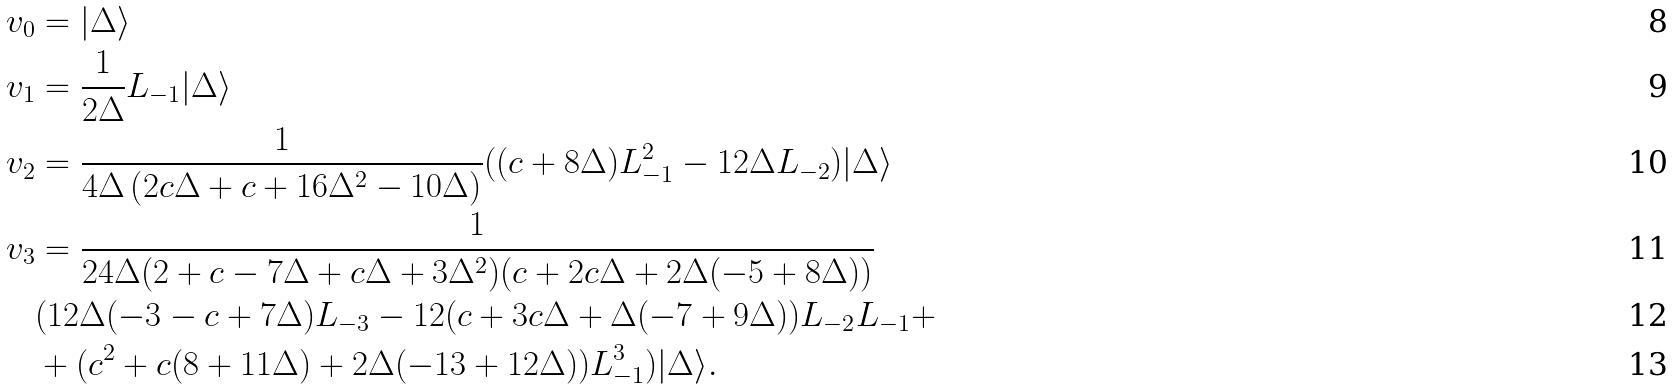Convert formula to latex. <formula><loc_0><loc_0><loc_500><loc_500>v _ { 0 } & = | \Delta \rangle \\ v _ { 1 } & = \frac { 1 } { 2 \Delta } L _ { - 1 } | \Delta \rangle \\ v _ { 2 } & = \frac { 1 } { 4 \Delta \left ( 2 c \Delta + c + 1 6 \Delta ^ { 2 } - 1 0 \Delta \right ) } ( ( c + 8 \Delta ) L _ { - 1 } ^ { 2 } - 1 2 \Delta L _ { - 2 } ) | \Delta \rangle \\ v _ { 3 } & = \frac { 1 } { 2 4 \Delta ( 2 + c - 7 \Delta + c \Delta + 3 \Delta ^ { 2 } ) ( c + 2 c \Delta + 2 \Delta ( - 5 + 8 \Delta ) ) } \\ & ( 1 2 \Delta ( - 3 - c + 7 \Delta ) L _ { - 3 } - 1 2 ( c + 3 c \Delta + \Delta ( - 7 + 9 \Delta ) ) L _ { - 2 } L _ { - 1 } + \\ & + ( c ^ { 2 } + c ( 8 + 1 1 \Delta ) + 2 \Delta ( - 1 3 + 1 2 \Delta ) ) L _ { - 1 } ^ { 3 } ) | \Delta \rangle .</formula> 